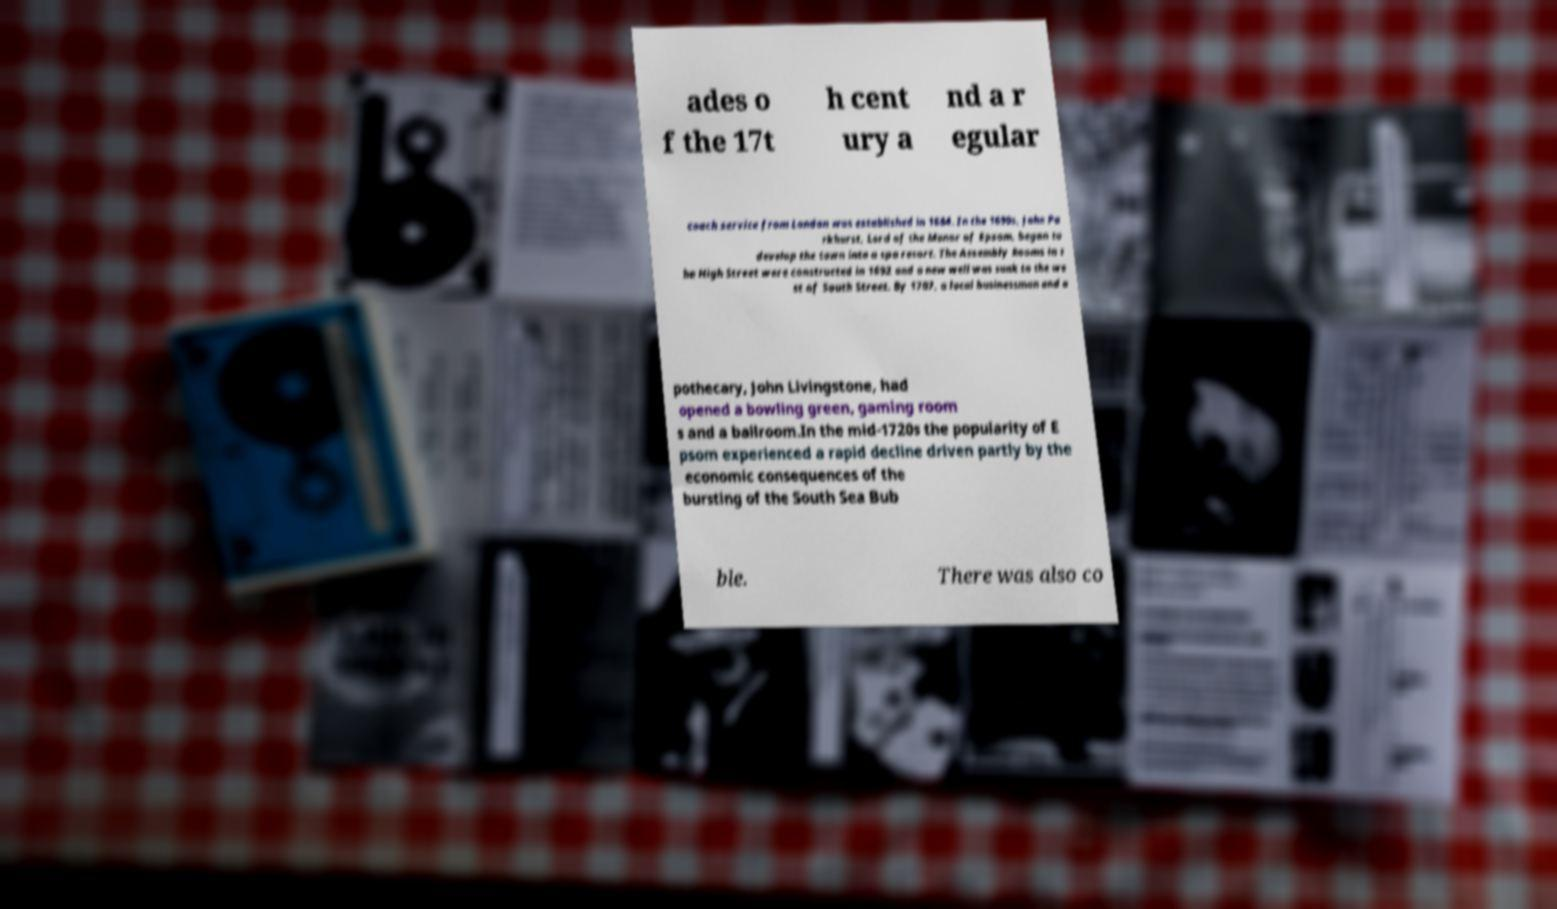Could you assist in decoding the text presented in this image and type it out clearly? ades o f the 17t h cent ury a nd a r egular coach service from London was established in 1684. In the 1690s, John Pa rkhurst, Lord of the Manor of Epsom, began to develop the town into a spa resort. The Assembly Rooms in t he High Street were constructed in 1692 and a new well was sunk to the we st of South Street. By 1707, a local businessman and a pothecary, John Livingstone, had opened a bowling green, gaming room s and a ballroom.In the mid-1720s the popularity of E psom experienced a rapid decline driven partly by the economic consequences of the bursting of the South Sea Bub ble. There was also co 